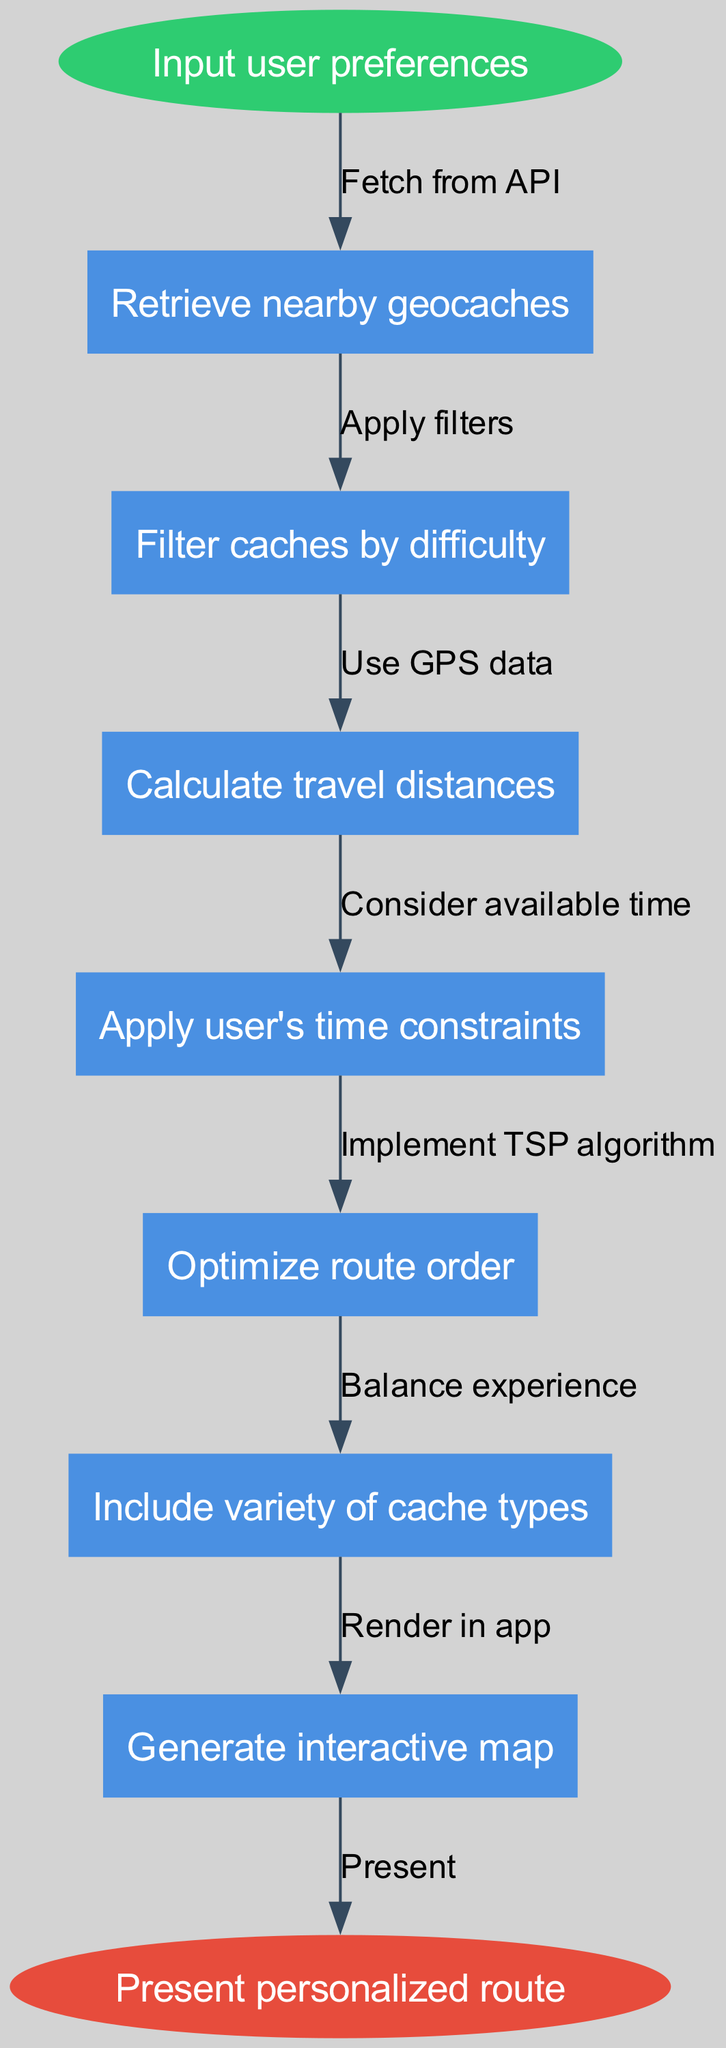What is the starting point of the flow chart? The flow chart begins with the node labeled "Input user preferences". This is the first action users need to take before the algorithm processes any data.
Answer: Input user preferences How many nodes are there in total? There are 7 nodes in the diagram, including 1 start node, 6 intermediate nodes, and 1 end node. Each node represents a distinct step in the algorithm.
Answer: 7 What is the last action before the personalized route is presented? The last action before reaching the end node "Present personalized route" is "Optimize route order". This node indicates that optimization takes place right before presenting the final outcome.
Answer: Optimize route order Which node follows "Calculate travel distances"? The node that follows "Calculate travel distances" is "Apply user's time constraints". This signifies that after determining distances, the algorithm considers the user's available time.
Answer: Apply user's time constraints What is the edge connecting "Retrieve nearby geocaches" to the next node called? The edge connecting "Retrieve nearby geocaches" to the next node is labeled "Fetch from API". This indicates that the action of retrieving geocaches requires fetching data from an external source.
Answer: Fetch from API What is the primary function of the "Generate interactive map" node? The "Generate interactive map" node is a final step that results in an interactive representation of the personalized route, informing users visually about their geocaching journey.
Answer: Generate interactive map How does the algorithm ensure variety in the geocaching experience? The algorithm ensures variety in the geocaching experience through the node "Include variety of cache types", which specifically addresses the inclusion of different types of caches in the route.
Answer: Include variety of cache types What role does the "Implement TSP algorithm" play in the route generation process? The "Implement TSP algorithm" node is crucial because it likely utilizes the Traveling Salesman Problem methodology to optimize the route order for efficiency and practicality, thereby enhancing the user's route experience.
Answer: Implement TSP algorithm 